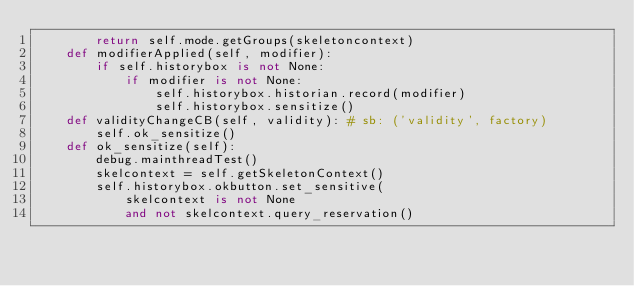Convert code to text. <code><loc_0><loc_0><loc_500><loc_500><_Python_>        return self.mode.getGroups(skeletoncontext)
    def modifierApplied(self, modifier): 
        if self.historybox is not None:
            if modifier is not None:
                self.historybox.historian.record(modifier)
                self.historybox.sensitize()
    def validityChangeCB(self, validity): # sb: ('validity', factory)
        self.ok_sensitize()
    def ok_sensitize(self):
        debug.mainthreadTest()
        skelcontext = self.getSkeletonContext()
        self.historybox.okbutton.set_sensitive(
            skelcontext is not None
            and not skelcontext.query_reservation()</code> 